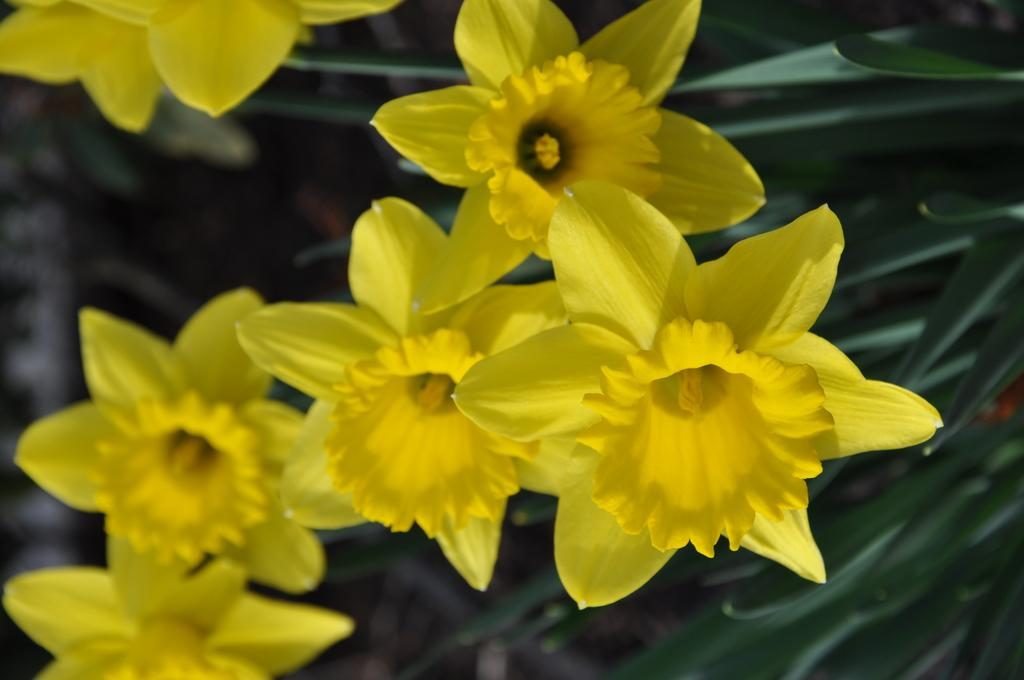What type of living organisms can be seen in the image? Plants can be seen in the image. What color are the flowers on the plants? The flowers on the plants are yellow. What color are the leaves on the plants? The leaves on the plants are green. How would you describe the background of the image? The background of the image is blurred. How many wings can be seen on the plants in the image? There are no wings visible on the plants in the image. 